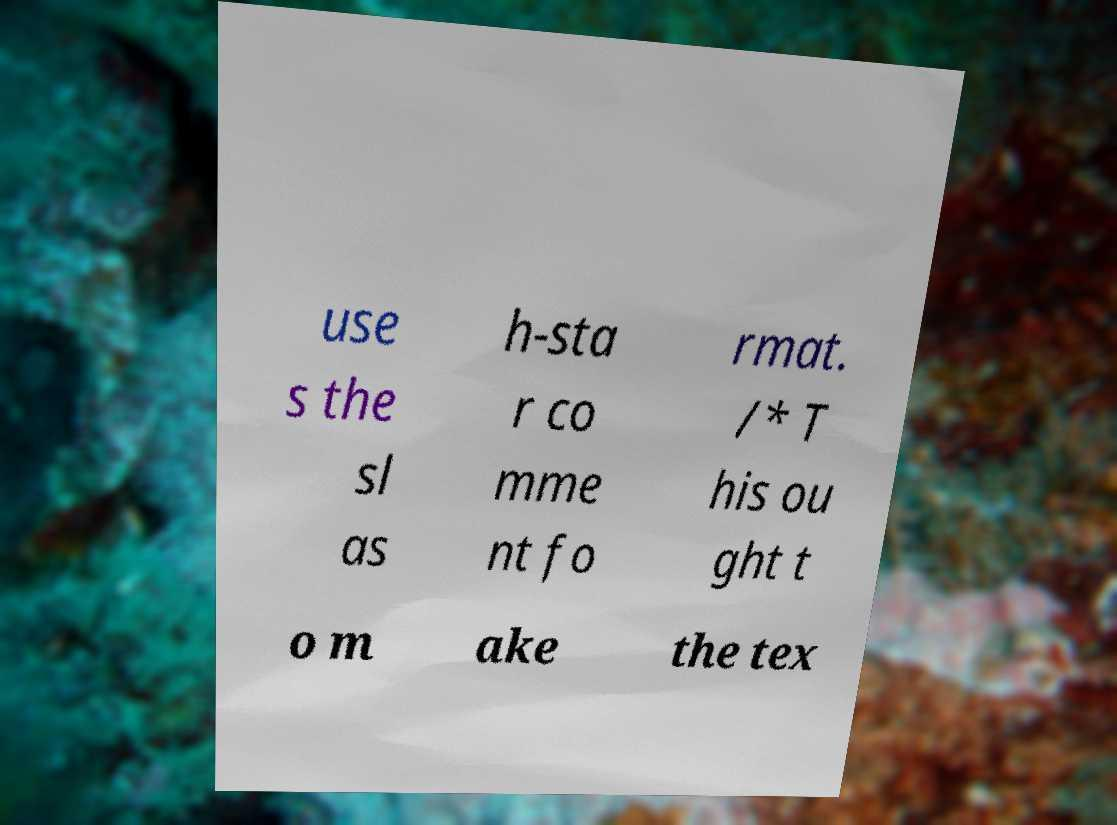Could you assist in decoding the text presented in this image and type it out clearly? use s the sl as h-sta r co mme nt fo rmat. /* T his ou ght t o m ake the tex 